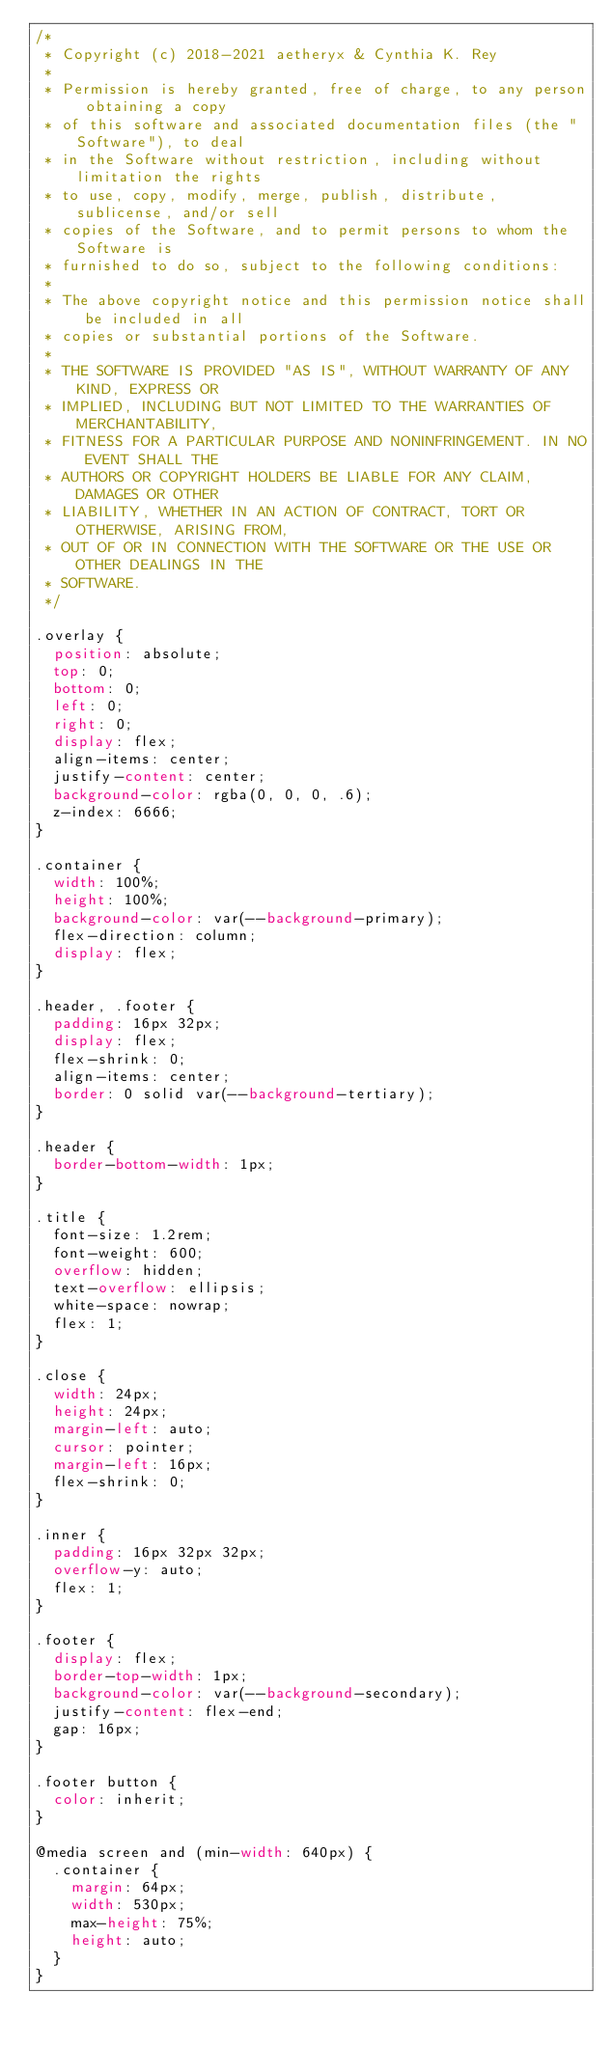Convert code to text. <code><loc_0><loc_0><loc_500><loc_500><_CSS_>/*
 * Copyright (c) 2018-2021 aetheryx & Cynthia K. Rey
 *
 * Permission is hereby granted, free of charge, to any person obtaining a copy
 * of this software and associated documentation files (the "Software"), to deal
 * in the Software without restriction, including without limitation the rights
 * to use, copy, modify, merge, publish, distribute, sublicense, and/or sell
 * copies of the Software, and to permit persons to whom the Software is
 * furnished to do so, subject to the following conditions:
 *
 * The above copyright notice and this permission notice shall be included in all
 * copies or substantial portions of the Software.
 *
 * THE SOFTWARE IS PROVIDED "AS IS", WITHOUT WARRANTY OF ANY KIND, EXPRESS OR
 * IMPLIED, INCLUDING BUT NOT LIMITED TO THE WARRANTIES OF MERCHANTABILITY,
 * FITNESS FOR A PARTICULAR PURPOSE AND NONINFRINGEMENT. IN NO EVENT SHALL THE
 * AUTHORS OR COPYRIGHT HOLDERS BE LIABLE FOR ANY CLAIM, DAMAGES OR OTHER
 * LIABILITY, WHETHER IN AN ACTION OF CONTRACT, TORT OR OTHERWISE, ARISING FROM,
 * OUT OF OR IN CONNECTION WITH THE SOFTWARE OR THE USE OR OTHER DEALINGS IN THE
 * SOFTWARE.
 */

.overlay {
  position: absolute;
  top: 0;
  bottom: 0;
  left: 0;
  right: 0;
  display: flex;
  align-items: center;
  justify-content: center;
  background-color: rgba(0, 0, 0, .6);
  z-index: 6666;
}

.container {
  width: 100%;
  height: 100%;
  background-color: var(--background-primary);
  flex-direction: column;
  display: flex;
}

.header, .footer {
  padding: 16px 32px;
  display: flex;
  flex-shrink: 0;
  align-items: center;
  border: 0 solid var(--background-tertiary);
}

.header {
  border-bottom-width: 1px;
}

.title {
  font-size: 1.2rem;
  font-weight: 600;
  overflow: hidden;
  text-overflow: ellipsis;
  white-space: nowrap;
  flex: 1;
}

.close {
  width: 24px;
  height: 24px;
  margin-left: auto;
  cursor: pointer;
  margin-left: 16px;
  flex-shrink: 0;
}

.inner {
  padding: 16px 32px 32px;
  overflow-y: auto;
  flex: 1;
}

.footer {
  display: flex;
  border-top-width: 1px;
  background-color: var(--background-secondary);
  justify-content: flex-end;
  gap: 16px;
}

.footer button {
  color: inherit;
}

@media screen and (min-width: 640px) {
  .container {
    margin: 64px;
    width: 530px;
    max-height: 75%;
    height: auto;
  }
}
</code> 